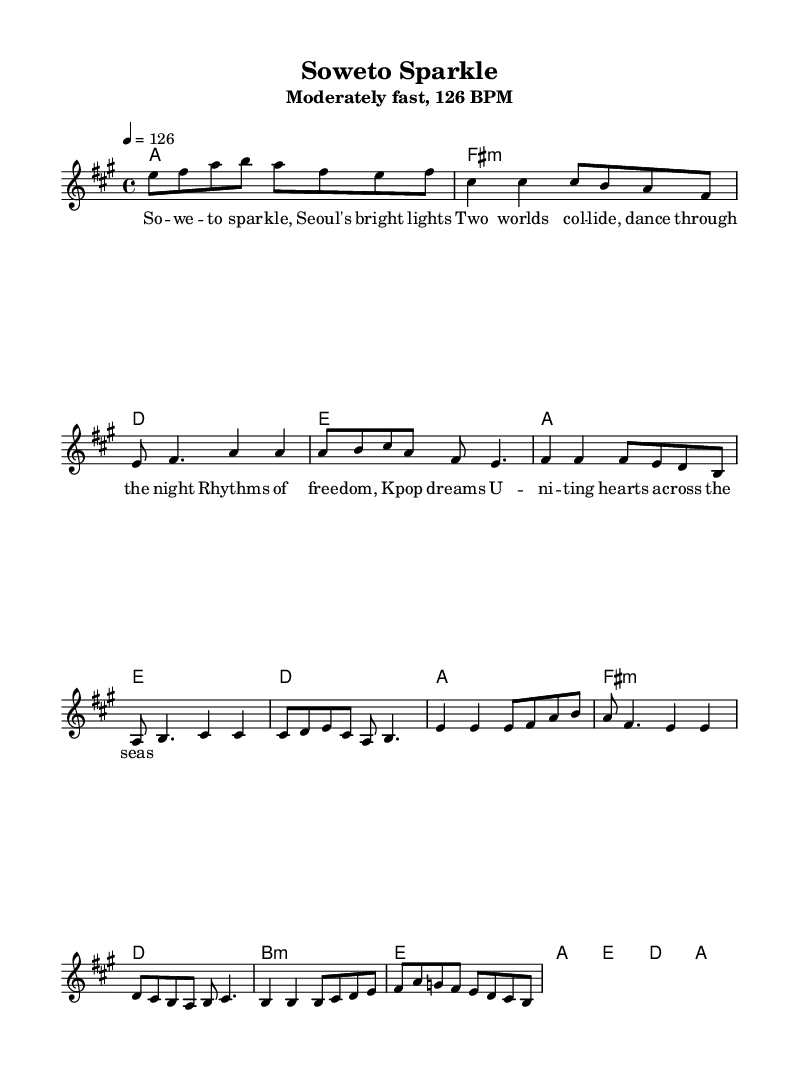What is the key signature of this music? The key signature is A major, which has three sharps: F sharp, C sharp, and G sharp. This can be identified at the beginning of the staff where the sharps are placed.
Answer: A major What is the time signature of this music? The time signature is 4/4, as indicated at the beginning of the score. This means there are four beats in each measure and the quarter note receives one beat.
Answer: 4/4 What is the tempo of the piece? The tempo of the piece is 126 BPM, which refers to beats per minute. This is indicated in the header, indicating the speed of the music.
Answer: 126 BPM What is the harmonic structure of the first chord? The first chord is A major, as indicated in the harmonies section, where the chord mode indicates an A major chord.
Answer: A major How many sections are there in this music piece? The music has three main sections: verse, pre-chorus, and chorus. These can be identified by the distinctive melodies and harmonic structures indicated in the score.
Answer: Three What is the lyric theme of the chorus? The lyric theme of the chorus celebrates the fusion of cultures, specifically referencing Soweto and Seoul, capturing a sense of unity and freedom in music. This can be derived from the lyrics provided under the melody.
Answer: Unity and freedom What is the main melodic motion in the bridge? The main melodic motion in the bridge consists of ascending and descending patterns, which create a dynamic contrast compared to other sections. This can be analyzed by looking at the pitch changes in the melody during the bridge.
Answer: Ascending and descending patterns 